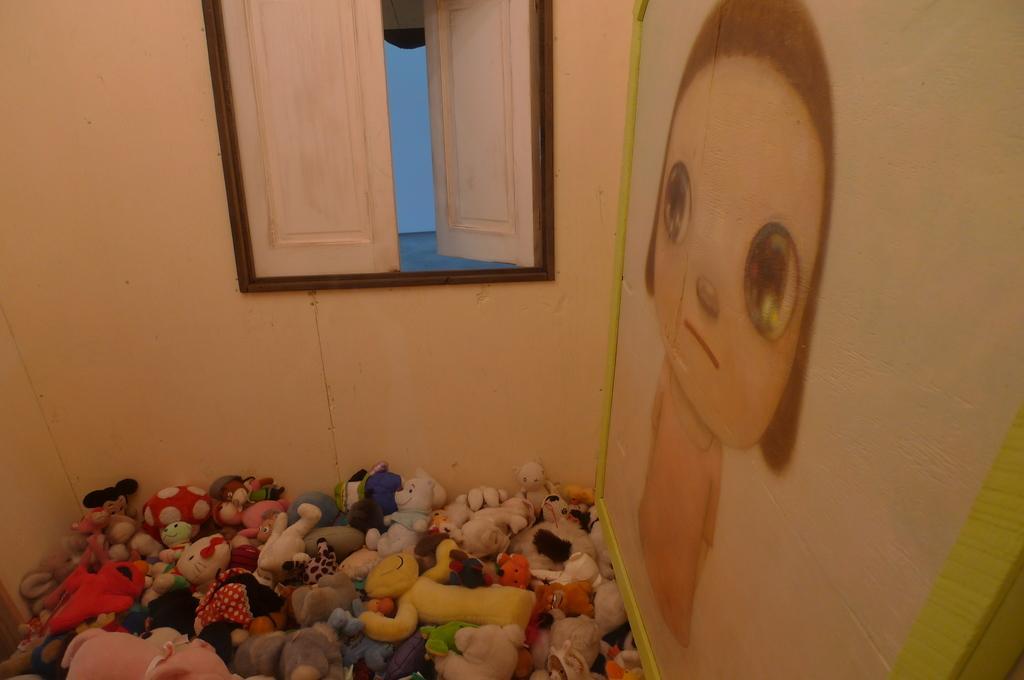How would you summarize this image in a sentence or two? In this image, I can see a window with doors, a wall and there is a photo frame. At the bottom of the image, I can see the toys. 